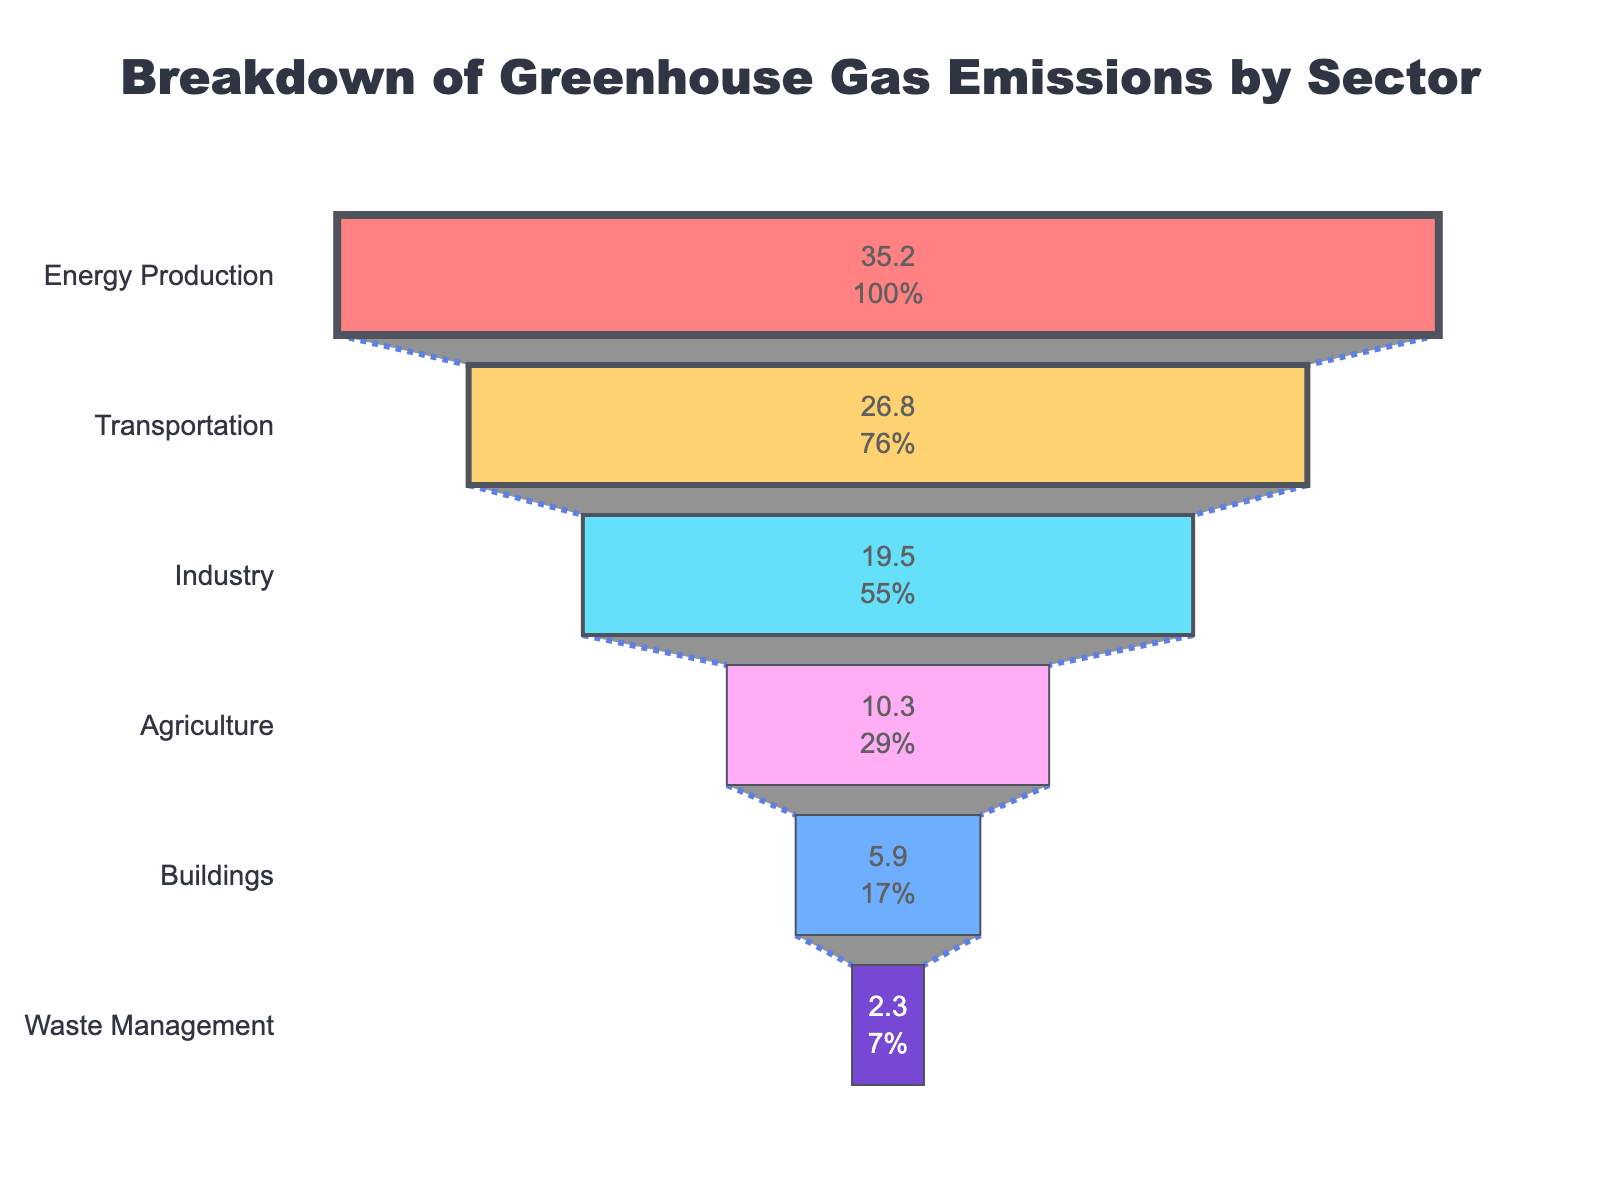What is the title of the funnel chart? The title of a chart is usually displayed prominently at the top. In this figure, the title is "Breakdown of Greenhouse Gas Emissions by Sector".
Answer: Breakdown of Greenhouse Gas Emissions by Sector How many sectors are listed in the funnel chart? Count the number of different sectors listed along the y-axis of the funnel chart.
Answer: 6 Which sector has the highest percentage of greenhouse gas emissions? Look for the sector at the widest part of the funnel chart, which represents the highest percentage. This is the first sector at the top of the chart.
Answer: Energy Production What is the smallest percentage of greenhouse gas emissions among the sectors? Look for the sector at the narrowest part of the funnel chart, which represents the smallest percentage. This is the last sector at the bottom of the chart.
Answer: 2.3% How much higher are the emissions for Energy Production compared to Waste Management? Subtract the emissions percentage of Waste Management from that of Energy Production. 35.2% - 2.3% = 32.9%
Answer: 32.9% What is the total percentage of emissions combined for Industry and Transportation sectors? Add the emissions percentages for Industry and Transportation sectors. 19.5% + 26.8% = 46.3%
Answer: 46.3% Order the sectors from highest to lowest percentage of emissions. Look at the y-axis from top to bottom and read the sectors in the order they are listed, since the funnel chart is already sorted by emissions percentage.
Answer: Energy Production, Transportation, Industry, Agriculture, Buildings, Waste Management What percentage of emissions does Agriculture contribute compared to Transportation? Divide the emissions percentage of Agriculture by that of Transportation and multiply by 100 to get the percentage. (10.3 / 26.8) * 100 ≈ 38.43%
Answer: 38.43% Are there any sectors with an emissions percentage below 5%? Check the sectors at the narrow end of the funnel and see if any have an emission percentage below 5%. The Buildings sector has 5.9% which is above 5%, but Waste Management has 2.3% which is below 5%.
Answer: Yes, Waste Management How does the emissions percentage of Buildings compare to Waste Management? Subtract the emissions percentage of Waste Management from that of Buildings. 5.9% - 2.3% = 3.6%
Answer: Buildings have 3.6% more emissions than Waste Management 